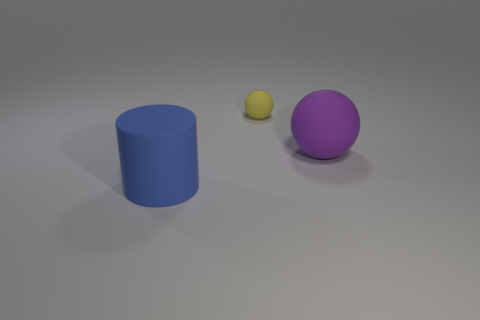Describe the positioning of the objects with respect to each other. The blue cylinder is on the left, the small yellow ball is in the center but closer to the cylinder, and the purple sphere is on the right but further back, similar to a diagonal line when viewed from the given perspective. 